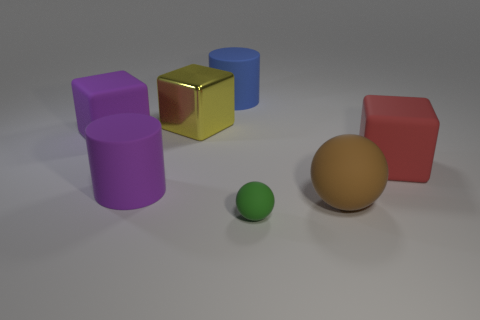Subtract all green blocks. Subtract all blue cylinders. How many blocks are left? 3 Add 1 large purple rubber cubes. How many objects exist? 8 Subtract all cubes. How many objects are left? 4 Add 1 metallic blocks. How many metallic blocks are left? 2 Add 3 green matte cylinders. How many green matte cylinders exist? 3 Subtract 0 gray cylinders. How many objects are left? 7 Subtract all small rubber cylinders. Subtract all brown rubber things. How many objects are left? 6 